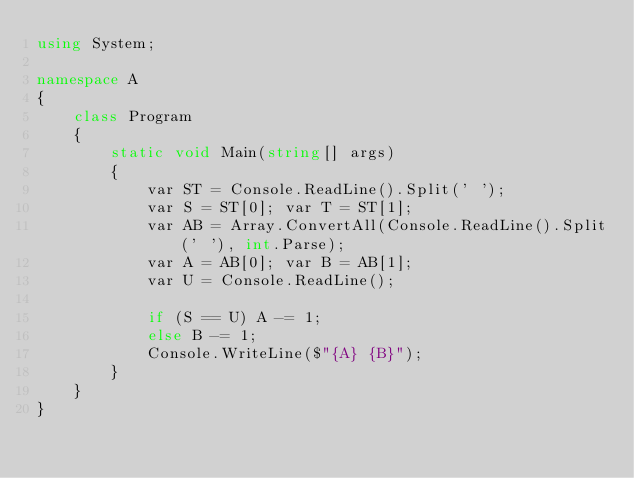<code> <loc_0><loc_0><loc_500><loc_500><_C#_>using System;

namespace A
{
    class Program
    {
        static void Main(string[] args)
        {
            var ST = Console.ReadLine().Split(' ');
            var S = ST[0]; var T = ST[1];
            var AB = Array.ConvertAll(Console.ReadLine().Split(' '), int.Parse);
            var A = AB[0]; var B = AB[1];
            var U = Console.ReadLine();

            if (S == U) A -= 1;
            else B -= 1;
            Console.WriteLine($"{A} {B}");
        }
    }
}
</code> 